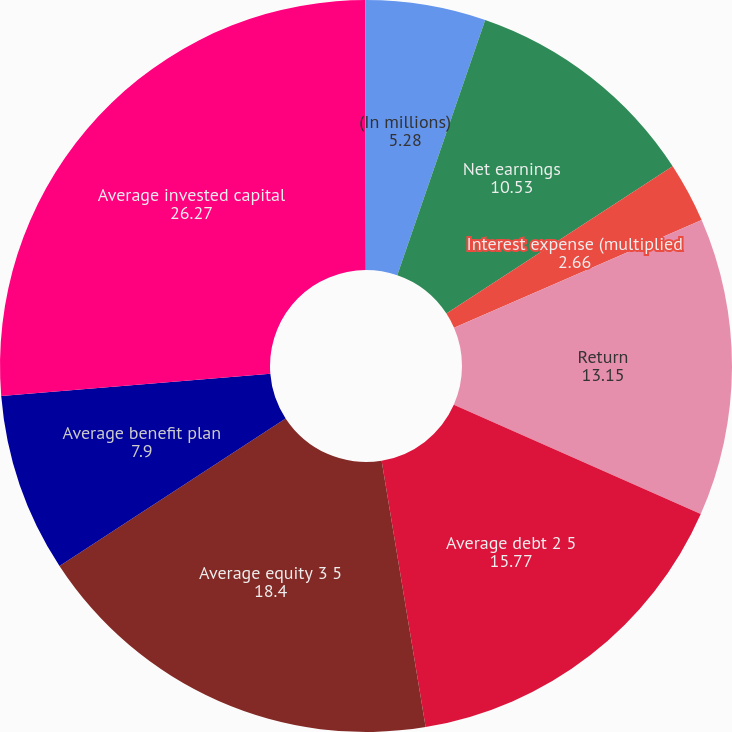<chart> <loc_0><loc_0><loc_500><loc_500><pie_chart><fcel>(In millions)<fcel>Net earnings<fcel>Interest expense (multiplied<fcel>Return<fcel>Average debt 2 5<fcel>Average equity 3 5<fcel>Average benefit plan<fcel>Average invested capital<fcel>Return on invested capital<nl><fcel>5.28%<fcel>10.53%<fcel>2.66%<fcel>13.15%<fcel>15.77%<fcel>18.4%<fcel>7.9%<fcel>26.27%<fcel>0.03%<nl></chart> 